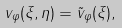Convert formula to latex. <formula><loc_0><loc_0><loc_500><loc_500>v _ { \varphi } ( \xi , \eta ) = \tilde { v } _ { \varphi } ( \xi ) ,</formula> 